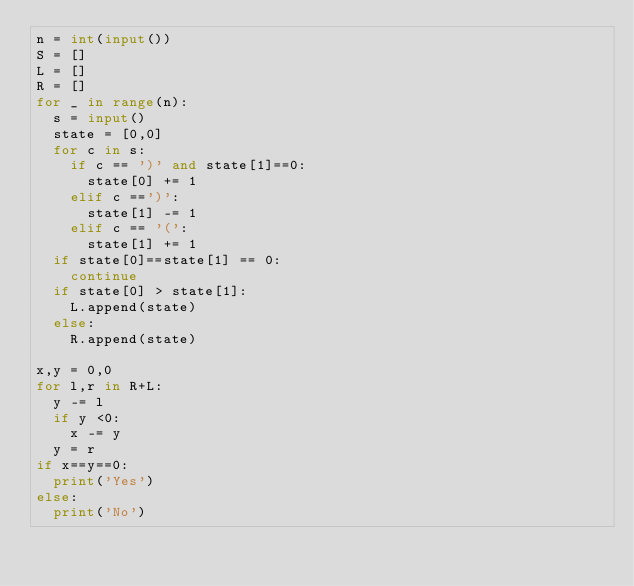Convert code to text. <code><loc_0><loc_0><loc_500><loc_500><_Python_>n = int(input())
S = []
L = []
R = []
for _ in range(n):
  s = input()
  state = [0,0]
  for c in s:
    if c == ')' and state[1]==0:
      state[0] += 1
    elif c ==')':
      state[1] -= 1
    elif c == '(':
      state[1] += 1
  if state[0]==state[1] == 0:
    continue
  if state[0] > state[1]:
    L.append(state)
  else:
    R.append(state)

x,y = 0,0
for l,r in R+L:
  y -= l
  if y <0:
    x -= y
  y = r
if x==y==0:
  print('Yes')
else:
  print('No')
  </code> 